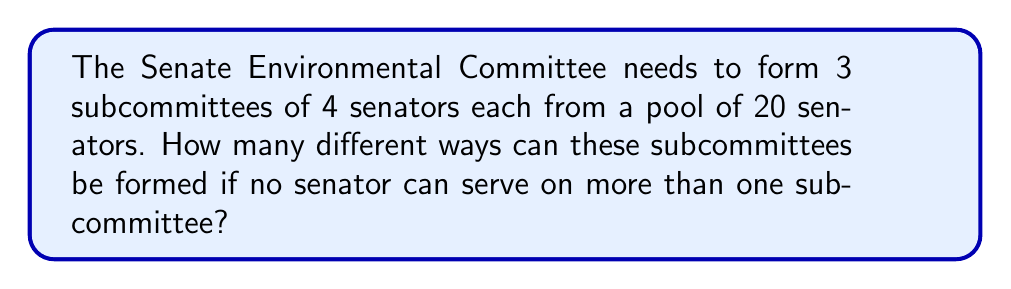Solve this math problem. Let's approach this step-by-step:

1) We need to select 12 senators out of 20 (4 for each of the 3 subcommittees).

2) The order of selecting the subcommittees matters, but the order within each subcommittee doesn't.

3) This is a combination problem where we're selecting groups without replacement.

4) We can solve this using the following steps:
   a) Choose 4 senators for the first subcommittee: $\binom{20}{4}$
   b) Choose 4 senators for the second subcommittee from the remaining 16: $\binom{16}{4}$
   c) Choose 4 senators for the third subcommittee from the remaining 12: $\binom{12}{4}$

5) Multiply these together using the multiplication principle:

   $$\binom{20}{4} \times \binom{16}{4} \times \binom{12}{4}$$

6) Calculate each combination:
   $$\binom{20}{4} = 4845$$
   $$\binom{16}{4} = 1820$$
   $$\binom{12}{4} = 495$$

7) Multiply the results:
   $$4845 \times 1820 \times 495 = 4,361,670,000$$

Therefore, there are 4,361,670,000 different ways to form these subcommittees.
Answer: 4,361,670,000 